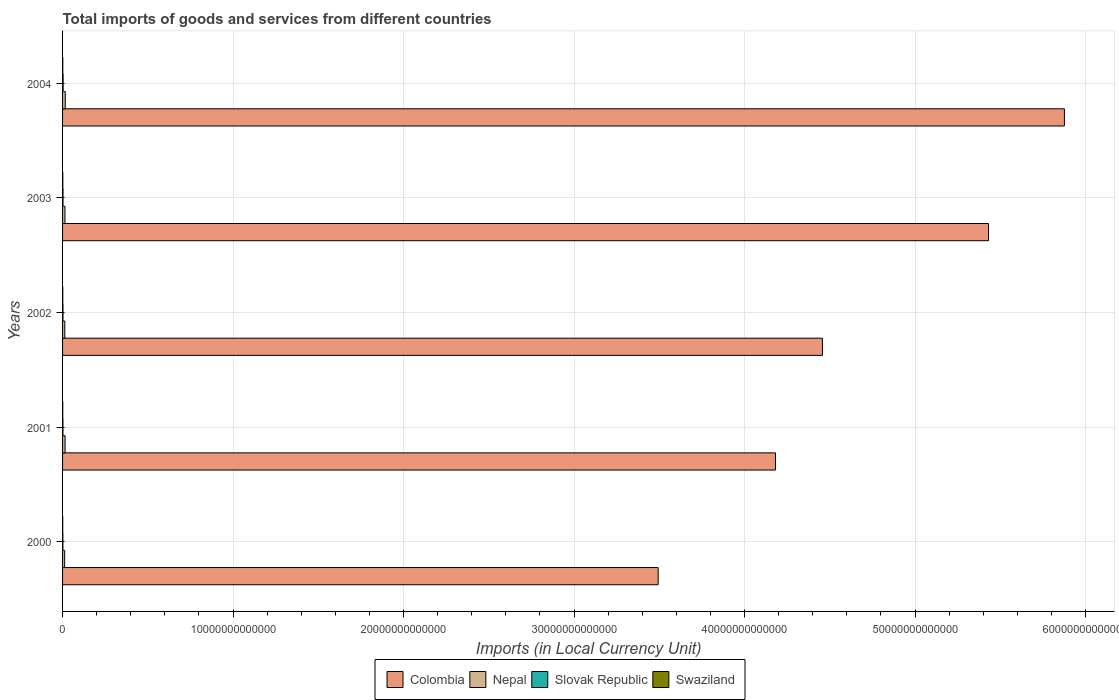How many groups of bars are there?
Ensure brevity in your answer.  5. Are the number of bars per tick equal to the number of legend labels?
Make the answer very short. Yes. How many bars are there on the 4th tick from the top?
Keep it short and to the point. 4. What is the label of the 2nd group of bars from the top?
Offer a very short reply. 2003. What is the Amount of goods and services imports in Colombia in 2004?
Offer a terse response. 5.88e+13. Across all years, what is the maximum Amount of goods and services imports in Swaziland?
Ensure brevity in your answer.  1.43e+1. Across all years, what is the minimum Amount of goods and services imports in Colombia?
Give a very brief answer. 3.49e+13. In which year was the Amount of goods and services imports in Swaziland maximum?
Provide a succinct answer. 2003. In which year was the Amount of goods and services imports in Nepal minimum?
Offer a terse response. 2000. What is the total Amount of goods and services imports in Nepal in the graph?
Give a very brief answer. 7.00e+11. What is the difference between the Amount of goods and services imports in Colombia in 2000 and that in 2003?
Your answer should be compact. -1.94e+13. What is the difference between the Amount of goods and services imports in Slovak Republic in 2003 and the Amount of goods and services imports in Colombia in 2002?
Keep it short and to the point. -4.45e+13. What is the average Amount of goods and services imports in Swaziland per year?
Offer a terse response. 1.24e+1. In the year 2000, what is the difference between the Amount of goods and services imports in Slovak Republic and Amount of goods and services imports in Colombia?
Your answer should be very brief. -3.49e+13. In how many years, is the Amount of goods and services imports in Swaziland greater than 46000000000000 LCU?
Ensure brevity in your answer.  0. What is the ratio of the Amount of goods and services imports in Swaziland in 2001 to that in 2002?
Make the answer very short. 0.88. Is the Amount of goods and services imports in Swaziland in 2001 less than that in 2003?
Make the answer very short. Yes. What is the difference between the highest and the second highest Amount of goods and services imports in Swaziland?
Provide a succinct answer. 6.15e+08. What is the difference between the highest and the lowest Amount of goods and services imports in Colombia?
Ensure brevity in your answer.  2.38e+13. In how many years, is the Amount of goods and services imports in Slovak Republic greater than the average Amount of goods and services imports in Slovak Republic taken over all years?
Your answer should be compact. 2. What does the 4th bar from the top in 2003 represents?
Ensure brevity in your answer.  Colombia. What does the 2nd bar from the bottom in 2001 represents?
Keep it short and to the point. Nepal. Is it the case that in every year, the sum of the Amount of goods and services imports in Nepal and Amount of goods and services imports in Colombia is greater than the Amount of goods and services imports in Swaziland?
Offer a very short reply. Yes. Are all the bars in the graph horizontal?
Offer a very short reply. Yes. What is the difference between two consecutive major ticks on the X-axis?
Make the answer very short. 1.00e+13. Does the graph contain grids?
Offer a terse response. Yes. How are the legend labels stacked?
Your answer should be very brief. Horizontal. What is the title of the graph?
Offer a very short reply. Total imports of goods and services from different countries. Does "French Polynesia" appear as one of the legend labels in the graph?
Keep it short and to the point. No. What is the label or title of the X-axis?
Provide a succinct answer. Imports (in Local Currency Unit). What is the label or title of the Y-axis?
Give a very brief answer. Years. What is the Imports (in Local Currency Unit) of Colombia in 2000?
Provide a short and direct response. 3.49e+13. What is the Imports (in Local Currency Unit) of Nepal in 2000?
Offer a very short reply. 1.23e+11. What is the Imports (in Local Currency Unit) in Slovak Republic in 2000?
Give a very brief answer. 1.79e+1. What is the Imports (in Local Currency Unit) of Swaziland in 2000?
Offer a very short reply. 9.31e+09. What is the Imports (in Local Currency Unit) of Colombia in 2001?
Keep it short and to the point. 4.18e+13. What is the Imports (in Local Currency Unit) of Nepal in 2001?
Give a very brief answer. 1.47e+11. What is the Imports (in Local Currency Unit) of Slovak Republic in 2001?
Your answer should be very brief. 2.26e+1. What is the Imports (in Local Currency Unit) in Swaziland in 2001?
Ensure brevity in your answer.  1.14e+1. What is the Imports (in Local Currency Unit) of Colombia in 2002?
Your response must be concise. 4.46e+13. What is the Imports (in Local Currency Unit) of Nepal in 2002?
Give a very brief answer. 1.31e+11. What is the Imports (in Local Currency Unit) of Slovak Republic in 2002?
Make the answer very short. 2.41e+1. What is the Imports (in Local Currency Unit) in Swaziland in 2002?
Ensure brevity in your answer.  1.30e+1. What is the Imports (in Local Currency Unit) of Colombia in 2003?
Ensure brevity in your answer.  5.43e+13. What is the Imports (in Local Currency Unit) in Nepal in 2003?
Your answer should be very brief. 1.41e+11. What is the Imports (in Local Currency Unit) in Slovak Republic in 2003?
Provide a short and direct response. 2.65e+1. What is the Imports (in Local Currency Unit) in Swaziland in 2003?
Keep it short and to the point. 1.43e+1. What is the Imports (in Local Currency Unit) in Colombia in 2004?
Keep it short and to the point. 5.88e+13. What is the Imports (in Local Currency Unit) in Nepal in 2004?
Your answer should be compact. 1.58e+11. What is the Imports (in Local Currency Unit) in Slovak Republic in 2004?
Provide a succinct answer. 3.29e+1. What is the Imports (in Local Currency Unit) of Swaziland in 2004?
Give a very brief answer. 1.37e+1. Across all years, what is the maximum Imports (in Local Currency Unit) of Colombia?
Your response must be concise. 5.88e+13. Across all years, what is the maximum Imports (in Local Currency Unit) of Nepal?
Offer a very short reply. 1.58e+11. Across all years, what is the maximum Imports (in Local Currency Unit) in Slovak Republic?
Offer a terse response. 3.29e+1. Across all years, what is the maximum Imports (in Local Currency Unit) in Swaziland?
Keep it short and to the point. 1.43e+1. Across all years, what is the minimum Imports (in Local Currency Unit) of Colombia?
Provide a short and direct response. 3.49e+13. Across all years, what is the minimum Imports (in Local Currency Unit) in Nepal?
Your answer should be compact. 1.23e+11. Across all years, what is the minimum Imports (in Local Currency Unit) in Slovak Republic?
Make the answer very short. 1.79e+1. Across all years, what is the minimum Imports (in Local Currency Unit) of Swaziland?
Offer a very short reply. 9.31e+09. What is the total Imports (in Local Currency Unit) in Colombia in the graph?
Provide a succinct answer. 2.34e+14. What is the total Imports (in Local Currency Unit) in Nepal in the graph?
Offer a terse response. 7.00e+11. What is the total Imports (in Local Currency Unit) of Slovak Republic in the graph?
Offer a very short reply. 1.24e+11. What is the total Imports (in Local Currency Unit) of Swaziland in the graph?
Your answer should be compact. 6.18e+1. What is the difference between the Imports (in Local Currency Unit) in Colombia in 2000 and that in 2001?
Your answer should be very brief. -6.88e+12. What is the difference between the Imports (in Local Currency Unit) of Nepal in 2000 and that in 2001?
Your answer should be compact. -2.39e+1. What is the difference between the Imports (in Local Currency Unit) of Slovak Republic in 2000 and that in 2001?
Your response must be concise. -4.69e+09. What is the difference between the Imports (in Local Currency Unit) of Swaziland in 2000 and that in 2001?
Provide a short and direct response. -2.13e+09. What is the difference between the Imports (in Local Currency Unit) in Colombia in 2000 and that in 2002?
Ensure brevity in your answer.  -9.64e+12. What is the difference between the Imports (in Local Currency Unit) in Nepal in 2000 and that in 2002?
Your answer should be very brief. -7.86e+09. What is the difference between the Imports (in Local Currency Unit) in Slovak Republic in 2000 and that in 2002?
Your answer should be compact. -6.23e+09. What is the difference between the Imports (in Local Currency Unit) in Swaziland in 2000 and that in 2002?
Provide a short and direct response. -3.73e+09. What is the difference between the Imports (in Local Currency Unit) of Colombia in 2000 and that in 2003?
Provide a succinct answer. -1.94e+13. What is the difference between the Imports (in Local Currency Unit) in Nepal in 2000 and that in 2003?
Your answer should be very brief. -1.75e+1. What is the difference between the Imports (in Local Currency Unit) of Slovak Republic in 2000 and that in 2003?
Make the answer very short. -8.64e+09. What is the difference between the Imports (in Local Currency Unit) of Swaziland in 2000 and that in 2003?
Your response must be concise. -4.98e+09. What is the difference between the Imports (in Local Currency Unit) in Colombia in 2000 and that in 2004?
Your answer should be compact. -2.38e+13. What is the difference between the Imports (in Local Currency Unit) in Nepal in 2000 and that in 2004?
Your answer should be very brief. -3.51e+1. What is the difference between the Imports (in Local Currency Unit) of Slovak Republic in 2000 and that in 2004?
Offer a terse response. -1.50e+1. What is the difference between the Imports (in Local Currency Unit) of Swaziland in 2000 and that in 2004?
Provide a short and direct response. -4.37e+09. What is the difference between the Imports (in Local Currency Unit) of Colombia in 2001 and that in 2002?
Provide a succinct answer. -2.75e+12. What is the difference between the Imports (in Local Currency Unit) of Nepal in 2001 and that in 2002?
Make the answer very short. 1.60e+1. What is the difference between the Imports (in Local Currency Unit) of Slovak Republic in 2001 and that in 2002?
Your response must be concise. -1.54e+09. What is the difference between the Imports (in Local Currency Unit) in Swaziland in 2001 and that in 2002?
Your response must be concise. -1.60e+09. What is the difference between the Imports (in Local Currency Unit) of Colombia in 2001 and that in 2003?
Your answer should be very brief. -1.25e+13. What is the difference between the Imports (in Local Currency Unit) of Nepal in 2001 and that in 2003?
Make the answer very short. 6.43e+09. What is the difference between the Imports (in Local Currency Unit) of Slovak Republic in 2001 and that in 2003?
Ensure brevity in your answer.  -3.95e+09. What is the difference between the Imports (in Local Currency Unit) of Swaziland in 2001 and that in 2003?
Offer a very short reply. -2.85e+09. What is the difference between the Imports (in Local Currency Unit) in Colombia in 2001 and that in 2004?
Provide a short and direct response. -1.69e+13. What is the difference between the Imports (in Local Currency Unit) in Nepal in 2001 and that in 2004?
Provide a succinct answer. -1.12e+1. What is the difference between the Imports (in Local Currency Unit) in Slovak Republic in 2001 and that in 2004?
Offer a very short reply. -1.04e+1. What is the difference between the Imports (in Local Currency Unit) of Swaziland in 2001 and that in 2004?
Your answer should be very brief. -2.24e+09. What is the difference between the Imports (in Local Currency Unit) in Colombia in 2002 and that in 2003?
Keep it short and to the point. -9.74e+12. What is the difference between the Imports (in Local Currency Unit) in Nepal in 2002 and that in 2003?
Your answer should be very brief. -9.61e+09. What is the difference between the Imports (in Local Currency Unit) in Slovak Republic in 2002 and that in 2003?
Offer a very short reply. -2.41e+09. What is the difference between the Imports (in Local Currency Unit) of Swaziland in 2002 and that in 2003?
Your response must be concise. -1.25e+09. What is the difference between the Imports (in Local Currency Unit) of Colombia in 2002 and that in 2004?
Offer a terse response. -1.42e+13. What is the difference between the Imports (in Local Currency Unit) of Nepal in 2002 and that in 2004?
Give a very brief answer. -2.72e+1. What is the difference between the Imports (in Local Currency Unit) in Slovak Republic in 2002 and that in 2004?
Offer a terse response. -8.81e+09. What is the difference between the Imports (in Local Currency Unit) in Swaziland in 2002 and that in 2004?
Offer a very short reply. -6.40e+08. What is the difference between the Imports (in Local Currency Unit) in Colombia in 2003 and that in 2004?
Offer a terse response. -4.45e+12. What is the difference between the Imports (in Local Currency Unit) in Nepal in 2003 and that in 2004?
Provide a short and direct response. -1.76e+1. What is the difference between the Imports (in Local Currency Unit) of Slovak Republic in 2003 and that in 2004?
Offer a terse response. -6.40e+09. What is the difference between the Imports (in Local Currency Unit) of Swaziland in 2003 and that in 2004?
Make the answer very short. 6.15e+08. What is the difference between the Imports (in Local Currency Unit) of Colombia in 2000 and the Imports (in Local Currency Unit) of Nepal in 2001?
Offer a very short reply. 3.48e+13. What is the difference between the Imports (in Local Currency Unit) in Colombia in 2000 and the Imports (in Local Currency Unit) in Slovak Republic in 2001?
Your answer should be very brief. 3.49e+13. What is the difference between the Imports (in Local Currency Unit) of Colombia in 2000 and the Imports (in Local Currency Unit) of Swaziland in 2001?
Your answer should be compact. 3.49e+13. What is the difference between the Imports (in Local Currency Unit) of Nepal in 2000 and the Imports (in Local Currency Unit) of Slovak Republic in 2001?
Ensure brevity in your answer.  1.00e+11. What is the difference between the Imports (in Local Currency Unit) in Nepal in 2000 and the Imports (in Local Currency Unit) in Swaziland in 2001?
Ensure brevity in your answer.  1.12e+11. What is the difference between the Imports (in Local Currency Unit) of Slovak Republic in 2000 and the Imports (in Local Currency Unit) of Swaziland in 2001?
Your response must be concise. 6.46e+09. What is the difference between the Imports (in Local Currency Unit) in Colombia in 2000 and the Imports (in Local Currency Unit) in Nepal in 2002?
Your response must be concise. 3.48e+13. What is the difference between the Imports (in Local Currency Unit) of Colombia in 2000 and the Imports (in Local Currency Unit) of Slovak Republic in 2002?
Your response must be concise. 3.49e+13. What is the difference between the Imports (in Local Currency Unit) in Colombia in 2000 and the Imports (in Local Currency Unit) in Swaziland in 2002?
Give a very brief answer. 3.49e+13. What is the difference between the Imports (in Local Currency Unit) of Nepal in 2000 and the Imports (in Local Currency Unit) of Slovak Republic in 2002?
Ensure brevity in your answer.  9.89e+1. What is the difference between the Imports (in Local Currency Unit) in Nepal in 2000 and the Imports (in Local Currency Unit) in Swaziland in 2002?
Provide a short and direct response. 1.10e+11. What is the difference between the Imports (in Local Currency Unit) in Slovak Republic in 2000 and the Imports (in Local Currency Unit) in Swaziland in 2002?
Offer a terse response. 4.86e+09. What is the difference between the Imports (in Local Currency Unit) of Colombia in 2000 and the Imports (in Local Currency Unit) of Nepal in 2003?
Provide a succinct answer. 3.48e+13. What is the difference between the Imports (in Local Currency Unit) of Colombia in 2000 and the Imports (in Local Currency Unit) of Slovak Republic in 2003?
Provide a short and direct response. 3.49e+13. What is the difference between the Imports (in Local Currency Unit) in Colombia in 2000 and the Imports (in Local Currency Unit) in Swaziland in 2003?
Ensure brevity in your answer.  3.49e+13. What is the difference between the Imports (in Local Currency Unit) of Nepal in 2000 and the Imports (in Local Currency Unit) of Slovak Republic in 2003?
Provide a succinct answer. 9.65e+1. What is the difference between the Imports (in Local Currency Unit) of Nepal in 2000 and the Imports (in Local Currency Unit) of Swaziland in 2003?
Your answer should be compact. 1.09e+11. What is the difference between the Imports (in Local Currency Unit) in Slovak Republic in 2000 and the Imports (in Local Currency Unit) in Swaziland in 2003?
Provide a succinct answer. 3.61e+09. What is the difference between the Imports (in Local Currency Unit) in Colombia in 2000 and the Imports (in Local Currency Unit) in Nepal in 2004?
Keep it short and to the point. 3.48e+13. What is the difference between the Imports (in Local Currency Unit) of Colombia in 2000 and the Imports (in Local Currency Unit) of Slovak Republic in 2004?
Offer a very short reply. 3.49e+13. What is the difference between the Imports (in Local Currency Unit) of Colombia in 2000 and the Imports (in Local Currency Unit) of Swaziland in 2004?
Provide a succinct answer. 3.49e+13. What is the difference between the Imports (in Local Currency Unit) in Nepal in 2000 and the Imports (in Local Currency Unit) in Slovak Republic in 2004?
Offer a very short reply. 9.01e+1. What is the difference between the Imports (in Local Currency Unit) in Nepal in 2000 and the Imports (in Local Currency Unit) in Swaziland in 2004?
Offer a very short reply. 1.09e+11. What is the difference between the Imports (in Local Currency Unit) in Slovak Republic in 2000 and the Imports (in Local Currency Unit) in Swaziland in 2004?
Provide a short and direct response. 4.22e+09. What is the difference between the Imports (in Local Currency Unit) of Colombia in 2001 and the Imports (in Local Currency Unit) of Nepal in 2002?
Keep it short and to the point. 4.17e+13. What is the difference between the Imports (in Local Currency Unit) in Colombia in 2001 and the Imports (in Local Currency Unit) in Slovak Republic in 2002?
Your response must be concise. 4.18e+13. What is the difference between the Imports (in Local Currency Unit) in Colombia in 2001 and the Imports (in Local Currency Unit) in Swaziland in 2002?
Make the answer very short. 4.18e+13. What is the difference between the Imports (in Local Currency Unit) in Nepal in 2001 and the Imports (in Local Currency Unit) in Slovak Republic in 2002?
Your response must be concise. 1.23e+11. What is the difference between the Imports (in Local Currency Unit) in Nepal in 2001 and the Imports (in Local Currency Unit) in Swaziland in 2002?
Your answer should be compact. 1.34e+11. What is the difference between the Imports (in Local Currency Unit) of Slovak Republic in 2001 and the Imports (in Local Currency Unit) of Swaziland in 2002?
Make the answer very short. 9.55e+09. What is the difference between the Imports (in Local Currency Unit) in Colombia in 2001 and the Imports (in Local Currency Unit) in Nepal in 2003?
Ensure brevity in your answer.  4.17e+13. What is the difference between the Imports (in Local Currency Unit) of Colombia in 2001 and the Imports (in Local Currency Unit) of Slovak Republic in 2003?
Ensure brevity in your answer.  4.18e+13. What is the difference between the Imports (in Local Currency Unit) of Colombia in 2001 and the Imports (in Local Currency Unit) of Swaziland in 2003?
Provide a succinct answer. 4.18e+13. What is the difference between the Imports (in Local Currency Unit) of Nepal in 2001 and the Imports (in Local Currency Unit) of Slovak Republic in 2003?
Offer a very short reply. 1.20e+11. What is the difference between the Imports (in Local Currency Unit) of Nepal in 2001 and the Imports (in Local Currency Unit) of Swaziland in 2003?
Your response must be concise. 1.33e+11. What is the difference between the Imports (in Local Currency Unit) in Slovak Republic in 2001 and the Imports (in Local Currency Unit) in Swaziland in 2003?
Keep it short and to the point. 8.29e+09. What is the difference between the Imports (in Local Currency Unit) in Colombia in 2001 and the Imports (in Local Currency Unit) in Nepal in 2004?
Offer a very short reply. 4.17e+13. What is the difference between the Imports (in Local Currency Unit) in Colombia in 2001 and the Imports (in Local Currency Unit) in Slovak Republic in 2004?
Your response must be concise. 4.18e+13. What is the difference between the Imports (in Local Currency Unit) in Colombia in 2001 and the Imports (in Local Currency Unit) in Swaziland in 2004?
Ensure brevity in your answer.  4.18e+13. What is the difference between the Imports (in Local Currency Unit) of Nepal in 2001 and the Imports (in Local Currency Unit) of Slovak Republic in 2004?
Offer a very short reply. 1.14e+11. What is the difference between the Imports (in Local Currency Unit) of Nepal in 2001 and the Imports (in Local Currency Unit) of Swaziland in 2004?
Your response must be concise. 1.33e+11. What is the difference between the Imports (in Local Currency Unit) in Slovak Republic in 2001 and the Imports (in Local Currency Unit) in Swaziland in 2004?
Offer a terse response. 8.91e+09. What is the difference between the Imports (in Local Currency Unit) in Colombia in 2002 and the Imports (in Local Currency Unit) in Nepal in 2003?
Your response must be concise. 4.44e+13. What is the difference between the Imports (in Local Currency Unit) of Colombia in 2002 and the Imports (in Local Currency Unit) of Slovak Republic in 2003?
Offer a terse response. 4.45e+13. What is the difference between the Imports (in Local Currency Unit) in Colombia in 2002 and the Imports (in Local Currency Unit) in Swaziland in 2003?
Provide a short and direct response. 4.46e+13. What is the difference between the Imports (in Local Currency Unit) in Nepal in 2002 and the Imports (in Local Currency Unit) in Slovak Republic in 2003?
Provide a short and direct response. 1.04e+11. What is the difference between the Imports (in Local Currency Unit) of Nepal in 2002 and the Imports (in Local Currency Unit) of Swaziland in 2003?
Your answer should be very brief. 1.17e+11. What is the difference between the Imports (in Local Currency Unit) of Slovak Republic in 2002 and the Imports (in Local Currency Unit) of Swaziland in 2003?
Offer a very short reply. 9.83e+09. What is the difference between the Imports (in Local Currency Unit) of Colombia in 2002 and the Imports (in Local Currency Unit) of Nepal in 2004?
Your answer should be compact. 4.44e+13. What is the difference between the Imports (in Local Currency Unit) of Colombia in 2002 and the Imports (in Local Currency Unit) of Slovak Republic in 2004?
Ensure brevity in your answer.  4.45e+13. What is the difference between the Imports (in Local Currency Unit) of Colombia in 2002 and the Imports (in Local Currency Unit) of Swaziland in 2004?
Your answer should be very brief. 4.46e+13. What is the difference between the Imports (in Local Currency Unit) of Nepal in 2002 and the Imports (in Local Currency Unit) of Slovak Republic in 2004?
Provide a succinct answer. 9.80e+1. What is the difference between the Imports (in Local Currency Unit) in Nepal in 2002 and the Imports (in Local Currency Unit) in Swaziland in 2004?
Make the answer very short. 1.17e+11. What is the difference between the Imports (in Local Currency Unit) in Slovak Republic in 2002 and the Imports (in Local Currency Unit) in Swaziland in 2004?
Offer a very short reply. 1.04e+1. What is the difference between the Imports (in Local Currency Unit) in Colombia in 2003 and the Imports (in Local Currency Unit) in Nepal in 2004?
Provide a short and direct response. 5.41e+13. What is the difference between the Imports (in Local Currency Unit) of Colombia in 2003 and the Imports (in Local Currency Unit) of Slovak Republic in 2004?
Provide a short and direct response. 5.43e+13. What is the difference between the Imports (in Local Currency Unit) in Colombia in 2003 and the Imports (in Local Currency Unit) in Swaziland in 2004?
Your response must be concise. 5.43e+13. What is the difference between the Imports (in Local Currency Unit) of Nepal in 2003 and the Imports (in Local Currency Unit) of Slovak Republic in 2004?
Your answer should be very brief. 1.08e+11. What is the difference between the Imports (in Local Currency Unit) of Nepal in 2003 and the Imports (in Local Currency Unit) of Swaziland in 2004?
Keep it short and to the point. 1.27e+11. What is the difference between the Imports (in Local Currency Unit) of Slovak Republic in 2003 and the Imports (in Local Currency Unit) of Swaziland in 2004?
Give a very brief answer. 1.29e+1. What is the average Imports (in Local Currency Unit) in Colombia per year?
Offer a terse response. 4.69e+13. What is the average Imports (in Local Currency Unit) of Nepal per year?
Your answer should be compact. 1.40e+11. What is the average Imports (in Local Currency Unit) of Slovak Republic per year?
Give a very brief answer. 2.48e+1. What is the average Imports (in Local Currency Unit) in Swaziland per year?
Give a very brief answer. 1.24e+1. In the year 2000, what is the difference between the Imports (in Local Currency Unit) of Colombia and Imports (in Local Currency Unit) of Nepal?
Offer a terse response. 3.48e+13. In the year 2000, what is the difference between the Imports (in Local Currency Unit) of Colombia and Imports (in Local Currency Unit) of Slovak Republic?
Offer a terse response. 3.49e+13. In the year 2000, what is the difference between the Imports (in Local Currency Unit) in Colombia and Imports (in Local Currency Unit) in Swaziland?
Make the answer very short. 3.49e+13. In the year 2000, what is the difference between the Imports (in Local Currency Unit) in Nepal and Imports (in Local Currency Unit) in Slovak Republic?
Your response must be concise. 1.05e+11. In the year 2000, what is the difference between the Imports (in Local Currency Unit) in Nepal and Imports (in Local Currency Unit) in Swaziland?
Provide a succinct answer. 1.14e+11. In the year 2000, what is the difference between the Imports (in Local Currency Unit) of Slovak Republic and Imports (in Local Currency Unit) of Swaziland?
Your response must be concise. 8.59e+09. In the year 2001, what is the difference between the Imports (in Local Currency Unit) of Colombia and Imports (in Local Currency Unit) of Nepal?
Provide a short and direct response. 4.17e+13. In the year 2001, what is the difference between the Imports (in Local Currency Unit) in Colombia and Imports (in Local Currency Unit) in Slovak Republic?
Give a very brief answer. 4.18e+13. In the year 2001, what is the difference between the Imports (in Local Currency Unit) of Colombia and Imports (in Local Currency Unit) of Swaziland?
Your answer should be compact. 4.18e+13. In the year 2001, what is the difference between the Imports (in Local Currency Unit) in Nepal and Imports (in Local Currency Unit) in Slovak Republic?
Your answer should be compact. 1.24e+11. In the year 2001, what is the difference between the Imports (in Local Currency Unit) in Nepal and Imports (in Local Currency Unit) in Swaziland?
Provide a short and direct response. 1.36e+11. In the year 2001, what is the difference between the Imports (in Local Currency Unit) in Slovak Republic and Imports (in Local Currency Unit) in Swaziland?
Offer a very short reply. 1.11e+1. In the year 2002, what is the difference between the Imports (in Local Currency Unit) of Colombia and Imports (in Local Currency Unit) of Nepal?
Your answer should be compact. 4.44e+13. In the year 2002, what is the difference between the Imports (in Local Currency Unit) of Colombia and Imports (in Local Currency Unit) of Slovak Republic?
Your answer should be very brief. 4.45e+13. In the year 2002, what is the difference between the Imports (in Local Currency Unit) in Colombia and Imports (in Local Currency Unit) in Swaziland?
Offer a very short reply. 4.46e+13. In the year 2002, what is the difference between the Imports (in Local Currency Unit) in Nepal and Imports (in Local Currency Unit) in Slovak Republic?
Your answer should be compact. 1.07e+11. In the year 2002, what is the difference between the Imports (in Local Currency Unit) in Nepal and Imports (in Local Currency Unit) in Swaziland?
Your answer should be very brief. 1.18e+11. In the year 2002, what is the difference between the Imports (in Local Currency Unit) of Slovak Republic and Imports (in Local Currency Unit) of Swaziland?
Give a very brief answer. 1.11e+1. In the year 2003, what is the difference between the Imports (in Local Currency Unit) in Colombia and Imports (in Local Currency Unit) in Nepal?
Provide a short and direct response. 5.42e+13. In the year 2003, what is the difference between the Imports (in Local Currency Unit) of Colombia and Imports (in Local Currency Unit) of Slovak Republic?
Keep it short and to the point. 5.43e+13. In the year 2003, what is the difference between the Imports (in Local Currency Unit) of Colombia and Imports (in Local Currency Unit) of Swaziland?
Ensure brevity in your answer.  5.43e+13. In the year 2003, what is the difference between the Imports (in Local Currency Unit) of Nepal and Imports (in Local Currency Unit) of Slovak Republic?
Ensure brevity in your answer.  1.14e+11. In the year 2003, what is the difference between the Imports (in Local Currency Unit) of Nepal and Imports (in Local Currency Unit) of Swaziland?
Keep it short and to the point. 1.26e+11. In the year 2003, what is the difference between the Imports (in Local Currency Unit) in Slovak Republic and Imports (in Local Currency Unit) in Swaziland?
Provide a succinct answer. 1.22e+1. In the year 2004, what is the difference between the Imports (in Local Currency Unit) of Colombia and Imports (in Local Currency Unit) of Nepal?
Ensure brevity in your answer.  5.86e+13. In the year 2004, what is the difference between the Imports (in Local Currency Unit) of Colombia and Imports (in Local Currency Unit) of Slovak Republic?
Offer a very short reply. 5.87e+13. In the year 2004, what is the difference between the Imports (in Local Currency Unit) in Colombia and Imports (in Local Currency Unit) in Swaziland?
Give a very brief answer. 5.87e+13. In the year 2004, what is the difference between the Imports (in Local Currency Unit) in Nepal and Imports (in Local Currency Unit) in Slovak Republic?
Offer a terse response. 1.25e+11. In the year 2004, what is the difference between the Imports (in Local Currency Unit) in Nepal and Imports (in Local Currency Unit) in Swaziland?
Your answer should be compact. 1.44e+11. In the year 2004, what is the difference between the Imports (in Local Currency Unit) of Slovak Republic and Imports (in Local Currency Unit) of Swaziland?
Ensure brevity in your answer.  1.93e+1. What is the ratio of the Imports (in Local Currency Unit) of Colombia in 2000 to that in 2001?
Offer a very short reply. 0.84. What is the ratio of the Imports (in Local Currency Unit) in Nepal in 2000 to that in 2001?
Offer a terse response. 0.84. What is the ratio of the Imports (in Local Currency Unit) in Slovak Republic in 2000 to that in 2001?
Make the answer very short. 0.79. What is the ratio of the Imports (in Local Currency Unit) of Swaziland in 2000 to that in 2001?
Ensure brevity in your answer.  0.81. What is the ratio of the Imports (in Local Currency Unit) of Colombia in 2000 to that in 2002?
Keep it short and to the point. 0.78. What is the ratio of the Imports (in Local Currency Unit) of Nepal in 2000 to that in 2002?
Ensure brevity in your answer.  0.94. What is the ratio of the Imports (in Local Currency Unit) in Slovak Republic in 2000 to that in 2002?
Offer a terse response. 0.74. What is the ratio of the Imports (in Local Currency Unit) of Swaziland in 2000 to that in 2002?
Your response must be concise. 0.71. What is the ratio of the Imports (in Local Currency Unit) in Colombia in 2000 to that in 2003?
Your answer should be compact. 0.64. What is the ratio of the Imports (in Local Currency Unit) of Nepal in 2000 to that in 2003?
Provide a short and direct response. 0.88. What is the ratio of the Imports (in Local Currency Unit) in Slovak Republic in 2000 to that in 2003?
Your answer should be very brief. 0.67. What is the ratio of the Imports (in Local Currency Unit) of Swaziland in 2000 to that in 2003?
Your answer should be very brief. 0.65. What is the ratio of the Imports (in Local Currency Unit) in Colombia in 2000 to that in 2004?
Give a very brief answer. 0.59. What is the ratio of the Imports (in Local Currency Unit) in Nepal in 2000 to that in 2004?
Your answer should be compact. 0.78. What is the ratio of the Imports (in Local Currency Unit) of Slovak Republic in 2000 to that in 2004?
Provide a succinct answer. 0.54. What is the ratio of the Imports (in Local Currency Unit) in Swaziland in 2000 to that in 2004?
Provide a succinct answer. 0.68. What is the ratio of the Imports (in Local Currency Unit) in Colombia in 2001 to that in 2002?
Provide a short and direct response. 0.94. What is the ratio of the Imports (in Local Currency Unit) in Nepal in 2001 to that in 2002?
Offer a very short reply. 1.12. What is the ratio of the Imports (in Local Currency Unit) of Slovak Republic in 2001 to that in 2002?
Offer a very short reply. 0.94. What is the ratio of the Imports (in Local Currency Unit) of Swaziland in 2001 to that in 2002?
Provide a short and direct response. 0.88. What is the ratio of the Imports (in Local Currency Unit) of Colombia in 2001 to that in 2003?
Your answer should be very brief. 0.77. What is the ratio of the Imports (in Local Currency Unit) in Nepal in 2001 to that in 2003?
Offer a very short reply. 1.05. What is the ratio of the Imports (in Local Currency Unit) in Slovak Republic in 2001 to that in 2003?
Ensure brevity in your answer.  0.85. What is the ratio of the Imports (in Local Currency Unit) in Swaziland in 2001 to that in 2003?
Provide a short and direct response. 0.8. What is the ratio of the Imports (in Local Currency Unit) of Colombia in 2001 to that in 2004?
Make the answer very short. 0.71. What is the ratio of the Imports (in Local Currency Unit) of Nepal in 2001 to that in 2004?
Your answer should be very brief. 0.93. What is the ratio of the Imports (in Local Currency Unit) in Slovak Republic in 2001 to that in 2004?
Your answer should be compact. 0.69. What is the ratio of the Imports (in Local Currency Unit) of Swaziland in 2001 to that in 2004?
Your answer should be very brief. 0.84. What is the ratio of the Imports (in Local Currency Unit) in Colombia in 2002 to that in 2003?
Offer a terse response. 0.82. What is the ratio of the Imports (in Local Currency Unit) of Nepal in 2002 to that in 2003?
Your answer should be very brief. 0.93. What is the ratio of the Imports (in Local Currency Unit) in Swaziland in 2002 to that in 2003?
Your answer should be very brief. 0.91. What is the ratio of the Imports (in Local Currency Unit) in Colombia in 2002 to that in 2004?
Give a very brief answer. 0.76. What is the ratio of the Imports (in Local Currency Unit) of Nepal in 2002 to that in 2004?
Offer a terse response. 0.83. What is the ratio of the Imports (in Local Currency Unit) in Slovak Republic in 2002 to that in 2004?
Provide a succinct answer. 0.73. What is the ratio of the Imports (in Local Currency Unit) in Swaziland in 2002 to that in 2004?
Offer a very short reply. 0.95. What is the ratio of the Imports (in Local Currency Unit) in Colombia in 2003 to that in 2004?
Make the answer very short. 0.92. What is the ratio of the Imports (in Local Currency Unit) in Nepal in 2003 to that in 2004?
Your answer should be very brief. 0.89. What is the ratio of the Imports (in Local Currency Unit) of Slovak Republic in 2003 to that in 2004?
Offer a very short reply. 0.81. What is the ratio of the Imports (in Local Currency Unit) in Swaziland in 2003 to that in 2004?
Offer a very short reply. 1.04. What is the difference between the highest and the second highest Imports (in Local Currency Unit) in Colombia?
Offer a very short reply. 4.45e+12. What is the difference between the highest and the second highest Imports (in Local Currency Unit) of Nepal?
Offer a terse response. 1.12e+1. What is the difference between the highest and the second highest Imports (in Local Currency Unit) of Slovak Republic?
Offer a very short reply. 6.40e+09. What is the difference between the highest and the second highest Imports (in Local Currency Unit) in Swaziland?
Give a very brief answer. 6.15e+08. What is the difference between the highest and the lowest Imports (in Local Currency Unit) of Colombia?
Give a very brief answer. 2.38e+13. What is the difference between the highest and the lowest Imports (in Local Currency Unit) in Nepal?
Ensure brevity in your answer.  3.51e+1. What is the difference between the highest and the lowest Imports (in Local Currency Unit) of Slovak Republic?
Your response must be concise. 1.50e+1. What is the difference between the highest and the lowest Imports (in Local Currency Unit) in Swaziland?
Your response must be concise. 4.98e+09. 